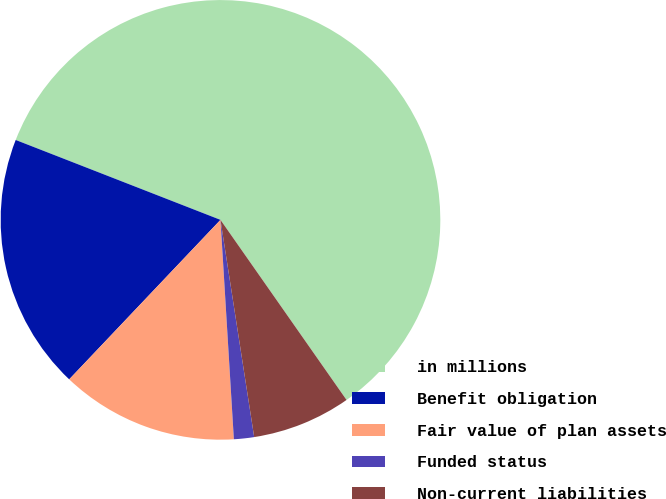Convert chart to OTSL. <chart><loc_0><loc_0><loc_500><loc_500><pie_chart><fcel>in millions<fcel>Benefit obligation<fcel>Fair value of plan assets<fcel>Funded status<fcel>Non-current liabilities<nl><fcel>59.36%<fcel>18.84%<fcel>13.05%<fcel>1.48%<fcel>7.27%<nl></chart> 